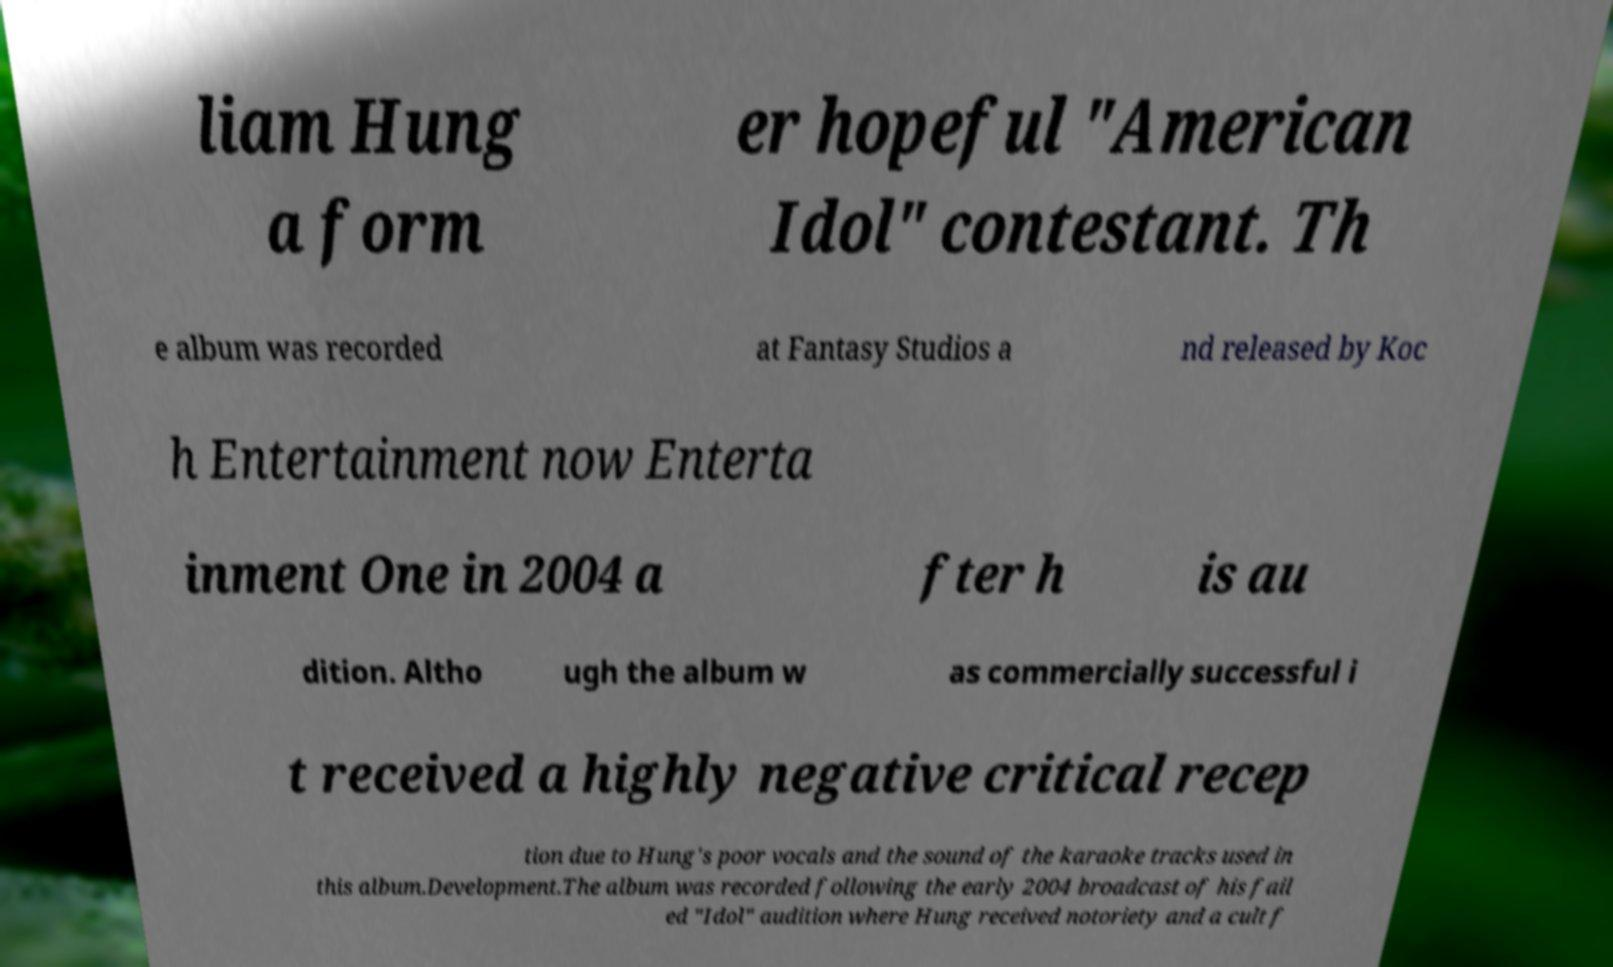Can you read and provide the text displayed in the image?This photo seems to have some interesting text. Can you extract and type it out for me? liam Hung a form er hopeful "American Idol" contestant. Th e album was recorded at Fantasy Studios a nd released by Koc h Entertainment now Enterta inment One in 2004 a fter h is au dition. Altho ugh the album w as commercially successful i t received a highly negative critical recep tion due to Hung's poor vocals and the sound of the karaoke tracks used in this album.Development.The album was recorded following the early 2004 broadcast of his fail ed "Idol" audition where Hung received notoriety and a cult f 